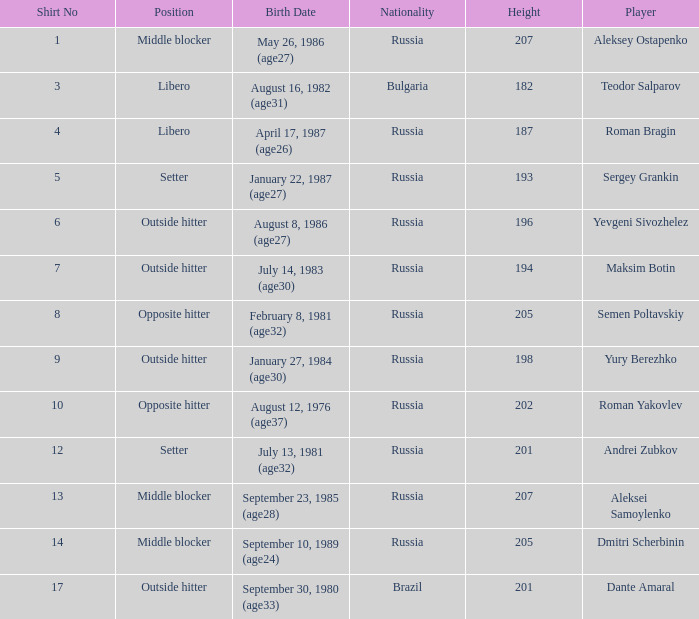How many position does Teodor Salparov play on?  1.0. 